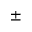Convert formula to latex. <formula><loc_0><loc_0><loc_500><loc_500>\pm</formula> 